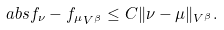Convert formula to latex. <formula><loc_0><loc_0><loc_500><loc_500>\ a b s { f _ { \nu } - f _ { \mu } } _ { V ^ { \beta } } \leq C \| \nu - \mu \| _ { V ^ { \beta } } .</formula> 